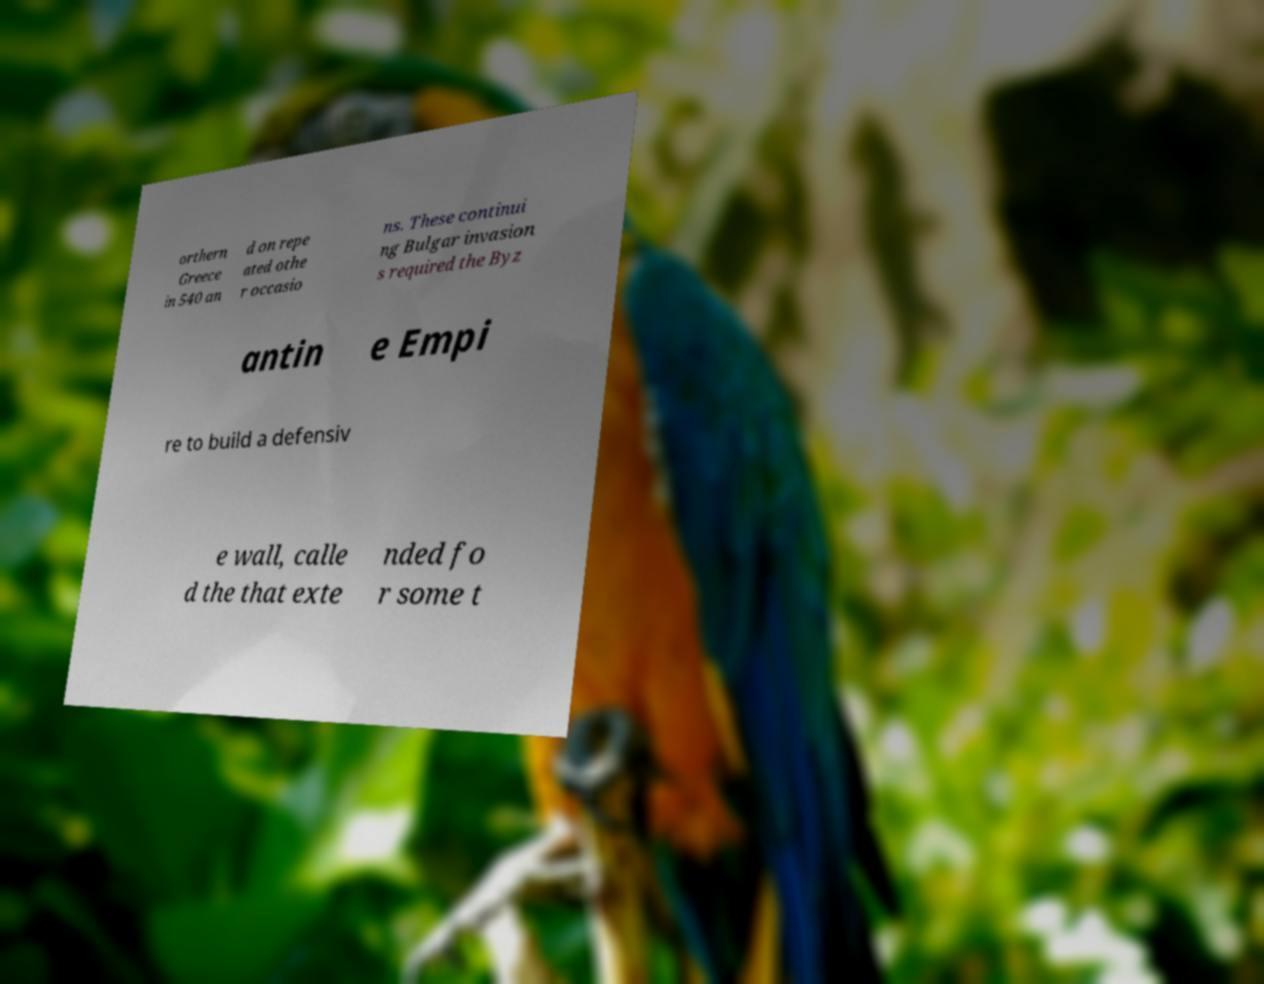Can you accurately transcribe the text from the provided image for me? orthern Greece in 540 an d on repe ated othe r occasio ns. These continui ng Bulgar invasion s required the Byz antin e Empi re to build a defensiv e wall, calle d the that exte nded fo r some t 